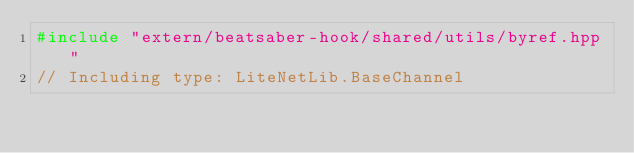<code> <loc_0><loc_0><loc_500><loc_500><_C++_>#include "extern/beatsaber-hook/shared/utils/byref.hpp"
// Including type: LiteNetLib.BaseChannel</code> 